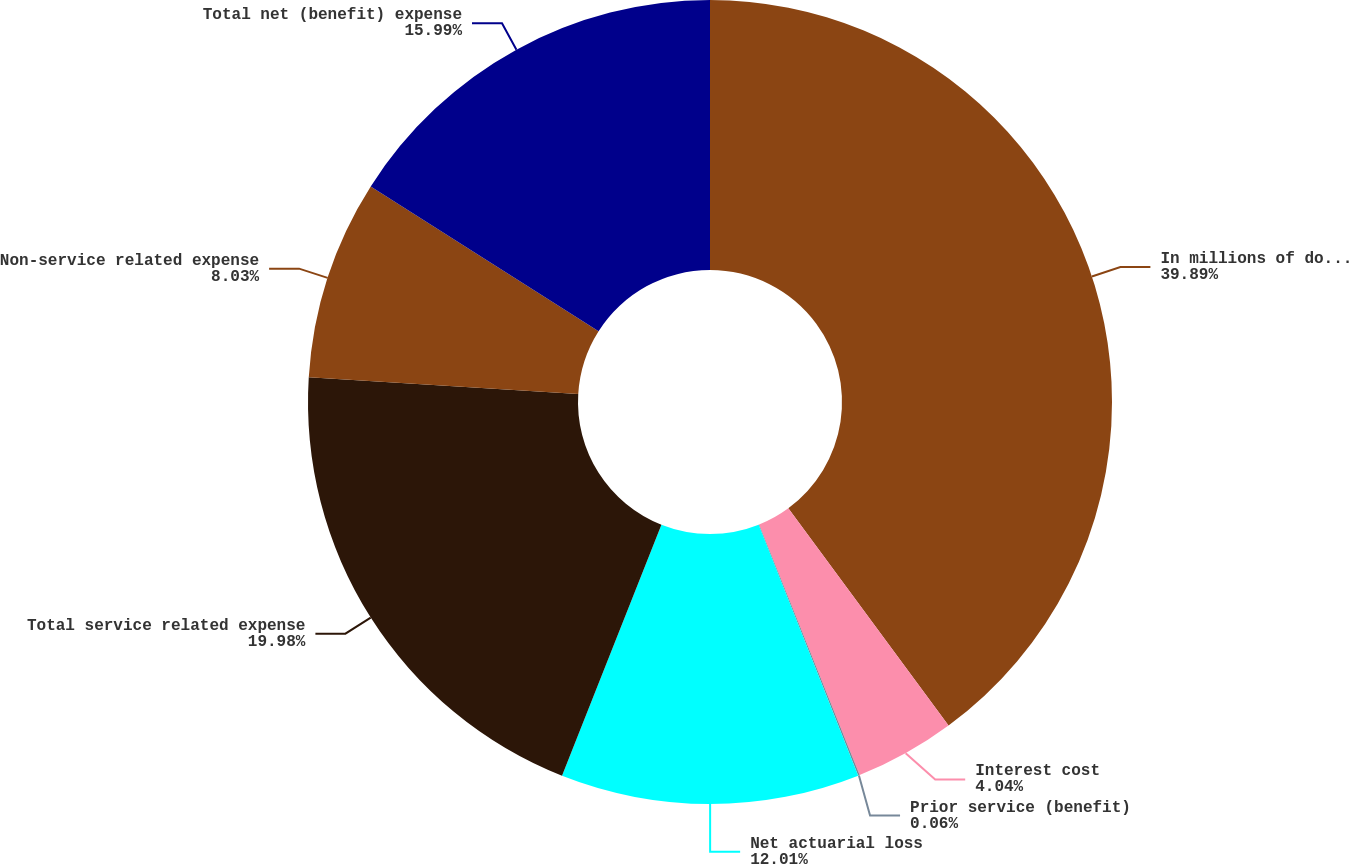Convert chart. <chart><loc_0><loc_0><loc_500><loc_500><pie_chart><fcel>In millions of dollars<fcel>Interest cost<fcel>Prior service (benefit)<fcel>Net actuarial loss<fcel>Total service related expense<fcel>Non-service related expense<fcel>Total net (benefit) expense<nl><fcel>39.89%<fcel>4.04%<fcel>0.06%<fcel>12.01%<fcel>19.98%<fcel>8.03%<fcel>15.99%<nl></chart> 